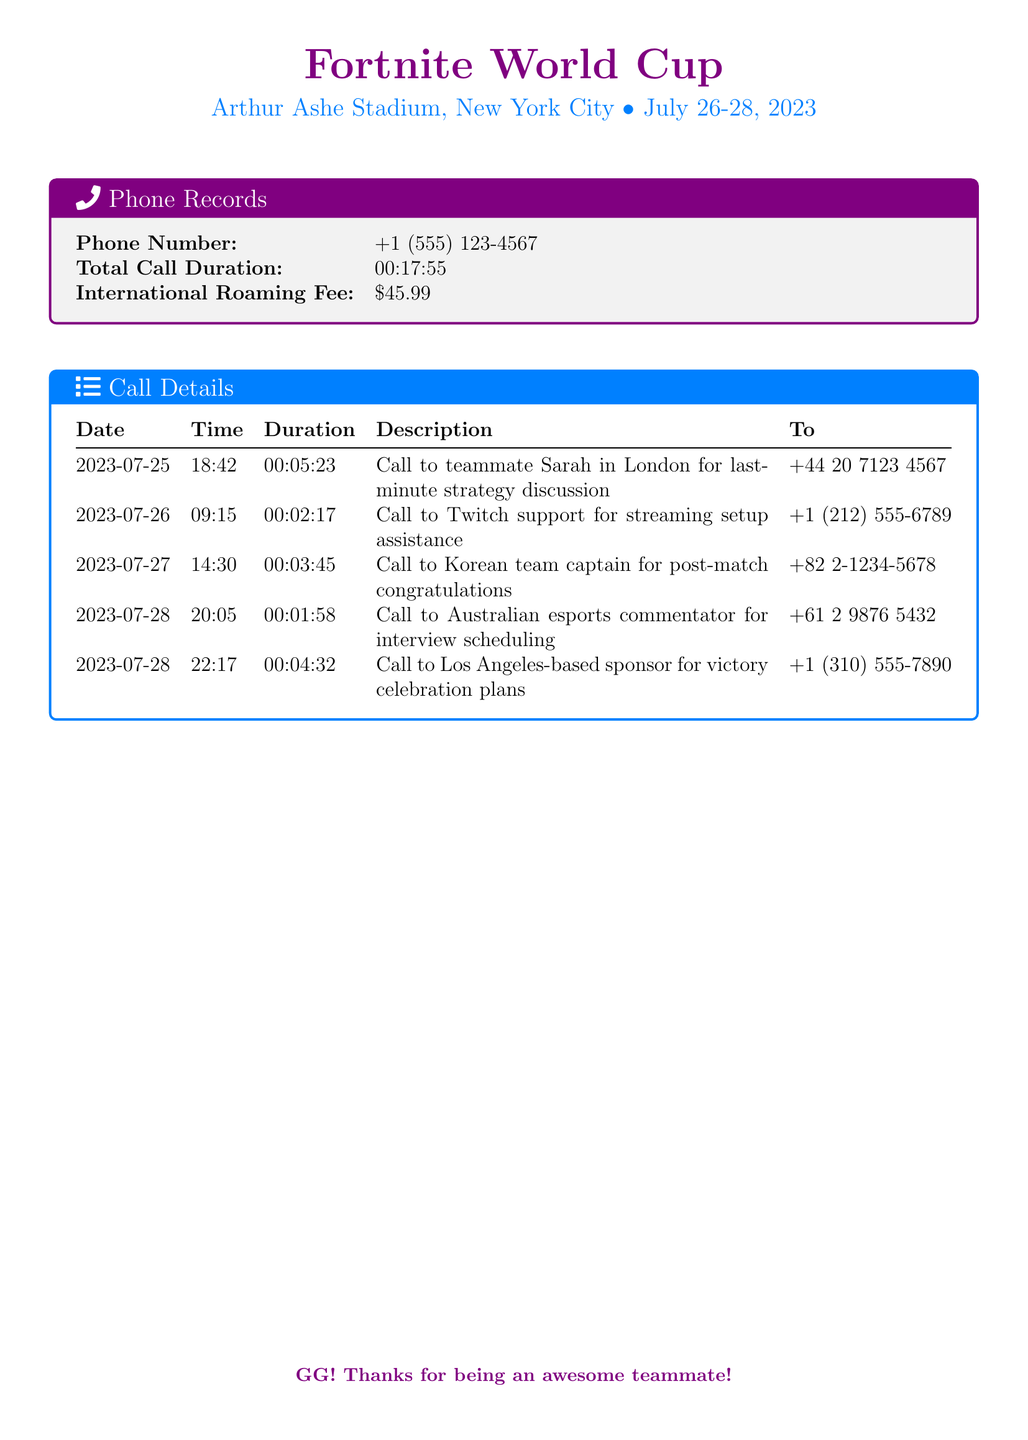what is the total call duration? The total call duration is recorded at the beginning of the document, summing all the individual call durations listed.
Answer: 00:17:55 how much is the international roaming fee? The international roaming fee is explicitly stated in the summary details of the document.
Answer: $45.99 what is the date of the last call? The date of the last call is listed in the call details section.
Answer: 2023-07-28 who was called for interview scheduling? The call details specify who was contacted for interview scheduling on the last day of the event.
Answer: Australian esports commentator how long was the call to teammate Sarah in London? The duration of the call to Sarah is provided in the details section and is specific to that call instance.
Answer: 00:05:23 which city is the esports commentator located in? The information about the esports commentator's location is contained within the call details.
Answer: Australian how many calls were made to international numbers? To determine this, count the calls presented in the call details that have international dialing codes.
Answer: 3 what is the name of the teammate called for a strategy discussion? The specific details of the call include the name of the teammate involved in the strategy discussion.
Answer: Sarah when did the call to Twitch support take place? The call to Twitch support is timestamped in the call details section.
Answer: 09:15 